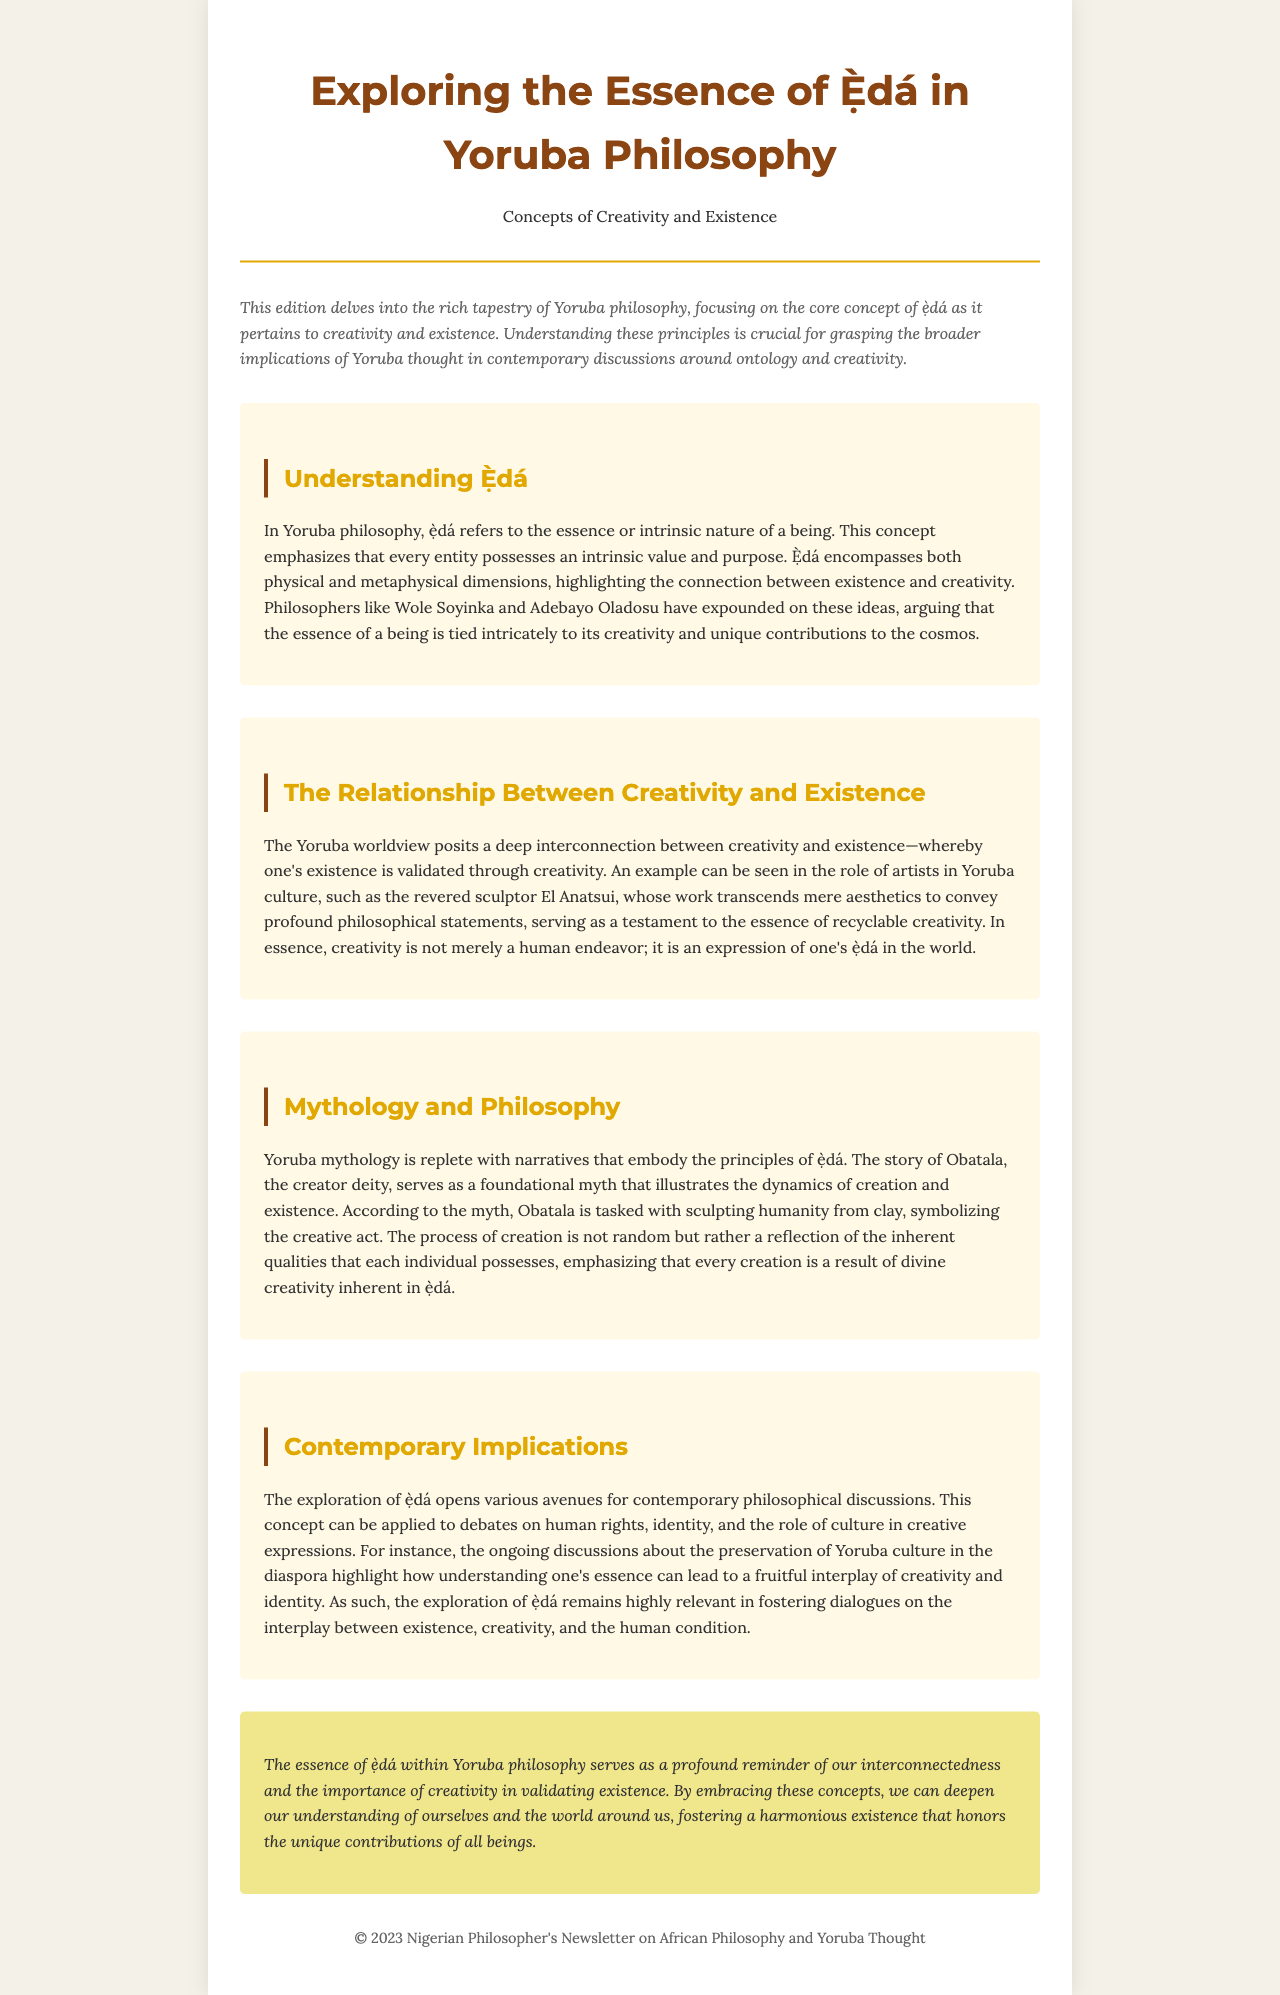What is the title of the newsletter? The title is prominently displayed at the top of the document.
Answer: Exploring the Essence of Ẹ̀dá in Yoruba Philosophy Who are the philosophers mentioned in the document? They are specifically noted in the section discussing the concept of ẹ̀dá.
Answer: Wole Soyinka and Adebayo Oladosu What does ẹ̀dá refer to in Yoruba philosophy? This definition is provided early in the discussion to set the context.
Answer: The essence or intrinsic nature of a being Which artist is mentioned as an example in relation to creativity? The artist is highlighted in the section that discusses the relationship between creativity and existence.
Answer: El Anatsui What mythological figure is associated with the process of creation? This figure is referenced in the mythology and philosophy section.
Answer: Obatala How does the document describe the interplay of creativity and identity? The exploration of the implications of ẹ̀dá is summarized in the contemporary implications section.
Answer: A fruitful interplay What is the background color of the newsletter? The background color is specified in the style section of the document.
Answer: #f4f1e8 What year is noted in the footer of the newsletter? The footer provides a date signifying the publication year.
Answer: 2023 What is the significance of creativity according to Yoruba philosophy? The conclusion emphasizes its role in validating existence.
Answer: Validating existence 